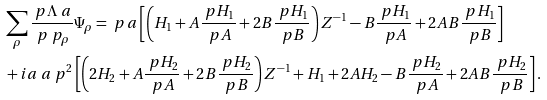Convert formula to latex. <formula><loc_0><loc_0><loc_500><loc_500>& \sum _ { \rho } \frac { \ p \Lambda _ { \ } a } { \ p \ p _ { \rho } } \Psi _ { \rho } = \ p _ { \ } a \left [ \left ( H _ { 1 } + A \frac { \ p H _ { 1 } } { \ p A } + 2 B \frac { \ p H _ { 1 } } { \ p B } \right ) Z ^ { - 1 } - B \frac { \ p H _ { 1 } } { \ p A } + 2 A B \frac { \ p H _ { 1 } } { \ p B } \right ] \\ & + i a _ { \ } a \ p ^ { 2 } \left [ \left ( 2 H _ { 2 } + A \frac { \ p H _ { 2 } } { \ p A } + 2 B \frac { \ p H _ { 2 } } { \ p B } \right ) Z ^ { - 1 } + H _ { 1 } + 2 A H _ { 2 } - B \frac { \ p H _ { 2 } } { \ p A } + 2 A B \frac { \ p H _ { 2 } } { \ p B } \right ] .</formula> 